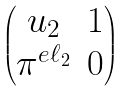<formula> <loc_0><loc_0><loc_500><loc_500>\begin{pmatrix} u _ { 2 } & 1 \\ \pi ^ { e \ell _ { 2 } } & 0 \end{pmatrix}</formula> 